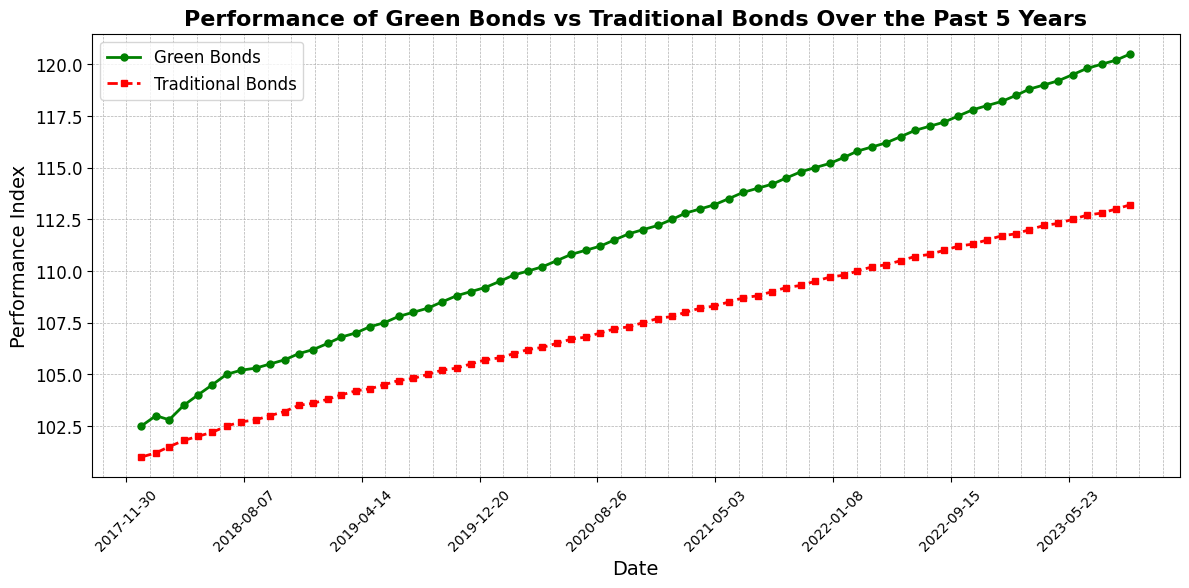What is the overall trend observed in the performance of Green Bonds over the past 5 years? The performance index of Green Bonds consistently increased over the 5-year period, starting at approximately 102.5 in early 2018 and reaching around 120.5 by October 2023.
Answer: Consistent increase Which type of bond showed a greater increase in performance over the 5-year period? Green Bonds started at an index of around 102.5 in January 2018 and reached about 120.5 by October 2023, an increase of 18. Traditional Bonds went from approximately 101.0 to 113.2 in the same period, an increase of 12.2. Therefore, Green Bonds had a greater increase.
Answer: Green Bonds What was the performance index for Traditional Bonds in January 2020 and January 2021? By referring to the plot, the performance index for Traditional Bonds in January 2020 was approximately 105.7, and in January 2021, it was around 107.7.
Answer: 105.7 and 107.7 How does the performance of Green Bonds in December 2022 compare to Traditional Bonds in the same month? In December 2022, Green Bonds had a performance index of approximately 118.0, whereas Traditional Bonds had a performance index around 111.5. Green Bonds outperformed Traditional Bonds by approximately 6.5 points.
Answer: Green Bonds outperformed Traditional Bonds by 6.5 points When comparing both types of bonds, which one demonstrates a smoother trend over the 5 years? Since both lines are mostly linear and smooth, both demonstrate relatively smooth trends. However, Traditional Bonds show a slightly smoother and steadier climb with less fluctuation compared to Green Bonds.
Answer: Traditional Bonds What is the difference in the performance index between Green Bonds and Traditional Bonds as of October 2023? By checking the end points on the plot, the performance index for Green Bonds is around 120.5, while it's approximately 113.2 for Traditional Bonds. The difference is 120.5 - 113.2 = 7.3 points.
Answer: 7.3 points Calculate the average yearly increase for Green Bonds over this 5-year period. The performance index for Green Bonds increased from roughly 102.5 in January 2018 to about 120.5 in October 2023. The increase over 5 years is 120.5 - 102.5 = 18. Dividing this by 5 years gives an average annual increase of 18/5 = 3.6 points.
Answer: 3.6 points What month and year did Green Bonds outperform 110 for the first time? By following the green line upwards, Green Bonds first crossed the 110 mark around June 2020.
Answer: June 2020 Did Traditional Bonds ever exceed the 112 performance index mark within the observed period, and if so, when? Traditional Bonds crossed the 112 index mark in August 2023. This can be observed by following the red line until it exceeds the 112 mark.
Answer: August 2023 